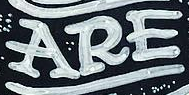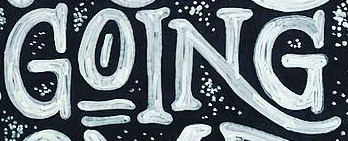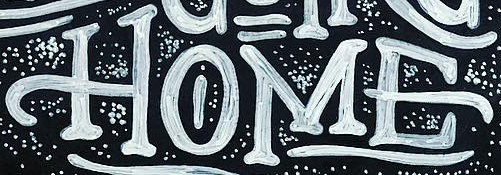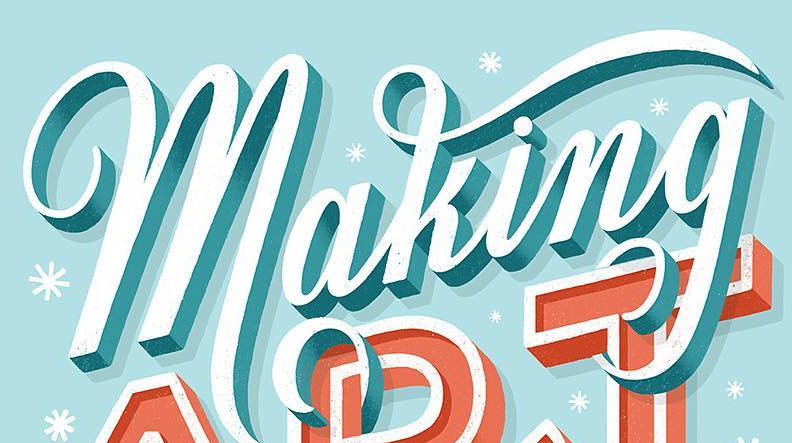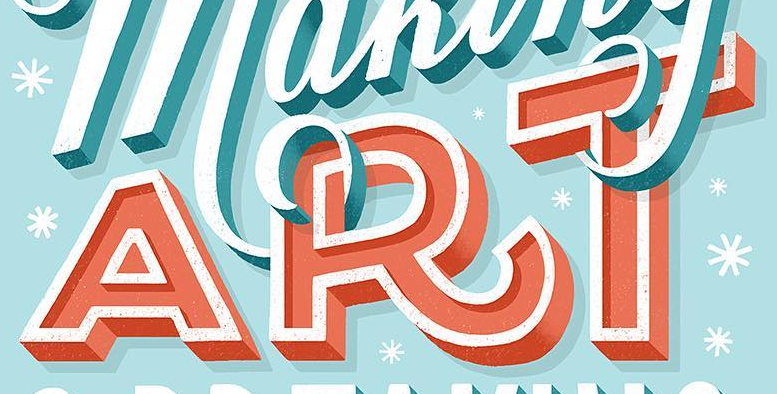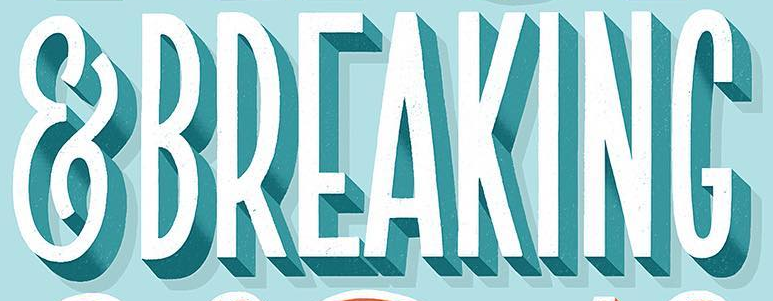Read the text content from these images in order, separated by a semicolon. ARE; GOING; HOME; making; ART; &BREAKING 